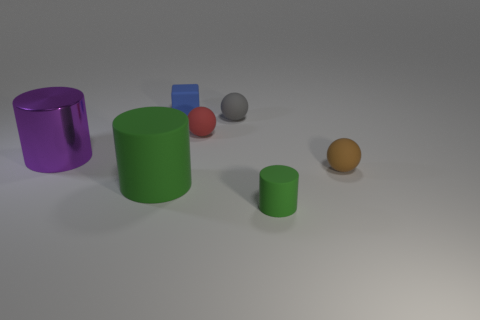How many gray things have the same shape as the large green thing?
Offer a very short reply. 0. What number of objects are there?
Offer a terse response. 7. There is a cylinder that is to the left of the small blue matte cube and right of the purple shiny object; what is its size?
Your answer should be very brief. Large. What shape is the brown object that is the same size as the blue block?
Keep it short and to the point. Sphere. There is a green object that is on the right side of the tiny gray matte sphere; is there a large green matte thing that is to the right of it?
Make the answer very short. No. What is the color of the tiny rubber object that is the same shape as the purple metal thing?
Make the answer very short. Green. There is a matte object that is to the left of the tiny blue rubber object; is it the same color as the large metal cylinder?
Ensure brevity in your answer.  No. How many objects are matte spheres in front of the large metallic object or tiny green objects?
Your answer should be compact. 2. What material is the large object that is in front of the matte ball right of the tiny matte thing in front of the tiny brown thing?
Make the answer very short. Rubber. Are there more blue cubes that are on the right side of the small brown matte object than tiny red things that are right of the gray ball?
Keep it short and to the point. No. 